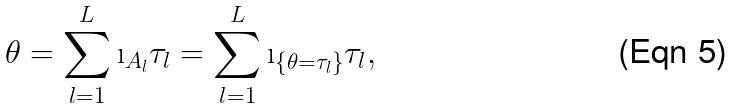<formula> <loc_0><loc_0><loc_500><loc_500>\theta = \sum _ { l = 1 } ^ { L } \i _ { A _ { l } } \tau _ { l } = \sum _ { l = 1 } ^ { L } \i _ { \{ \theta = \tau _ { l } \} } \tau _ { l } ,</formula> 